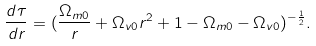Convert formula to latex. <formula><loc_0><loc_0><loc_500><loc_500>\frac { d \tau } { d r } = ( \frac { \Omega _ { m 0 } } { r } + \Omega _ { v 0 } r ^ { 2 } + 1 - \Omega _ { m 0 } - \Omega _ { v 0 } ) ^ { - \frac { 1 } { 2 } } .</formula> 